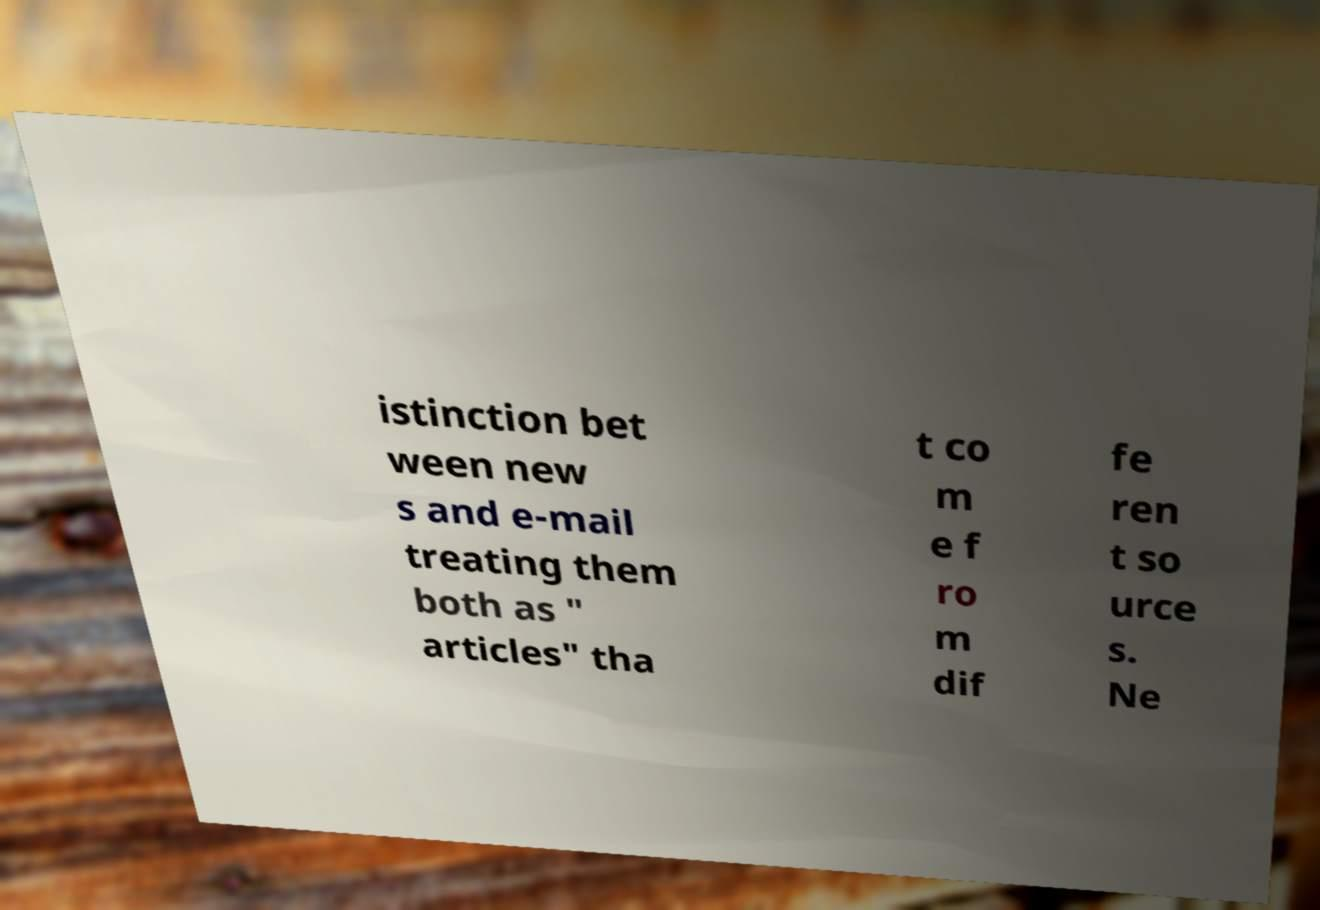For documentation purposes, I need the text within this image transcribed. Could you provide that? istinction bet ween new s and e-mail treating them both as " articles" tha t co m e f ro m dif fe ren t so urce s. Ne 